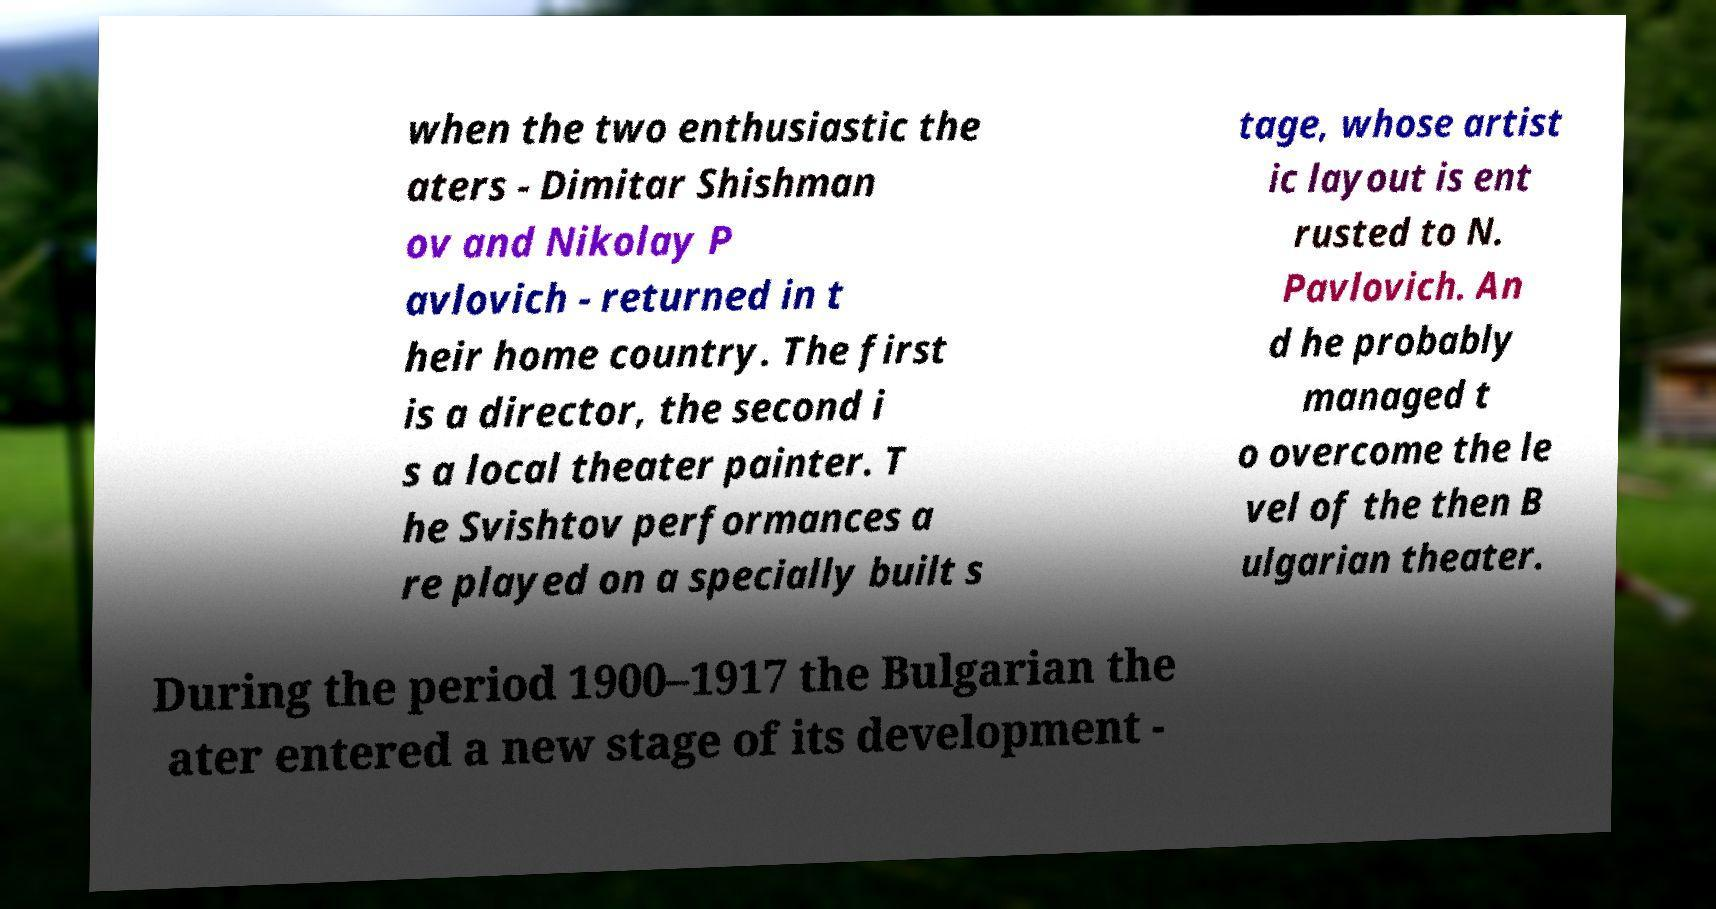Could you assist in decoding the text presented in this image and type it out clearly? when the two enthusiastic the aters - Dimitar Shishman ov and Nikolay P avlovich - returned in t heir home country. The first is a director, the second i s a local theater painter. T he Svishtov performances a re played on a specially built s tage, whose artist ic layout is ent rusted to N. Pavlovich. An d he probably managed t o overcome the le vel of the then B ulgarian theater. During the period 1900–1917 the Bulgarian the ater entered a new stage of its development - 